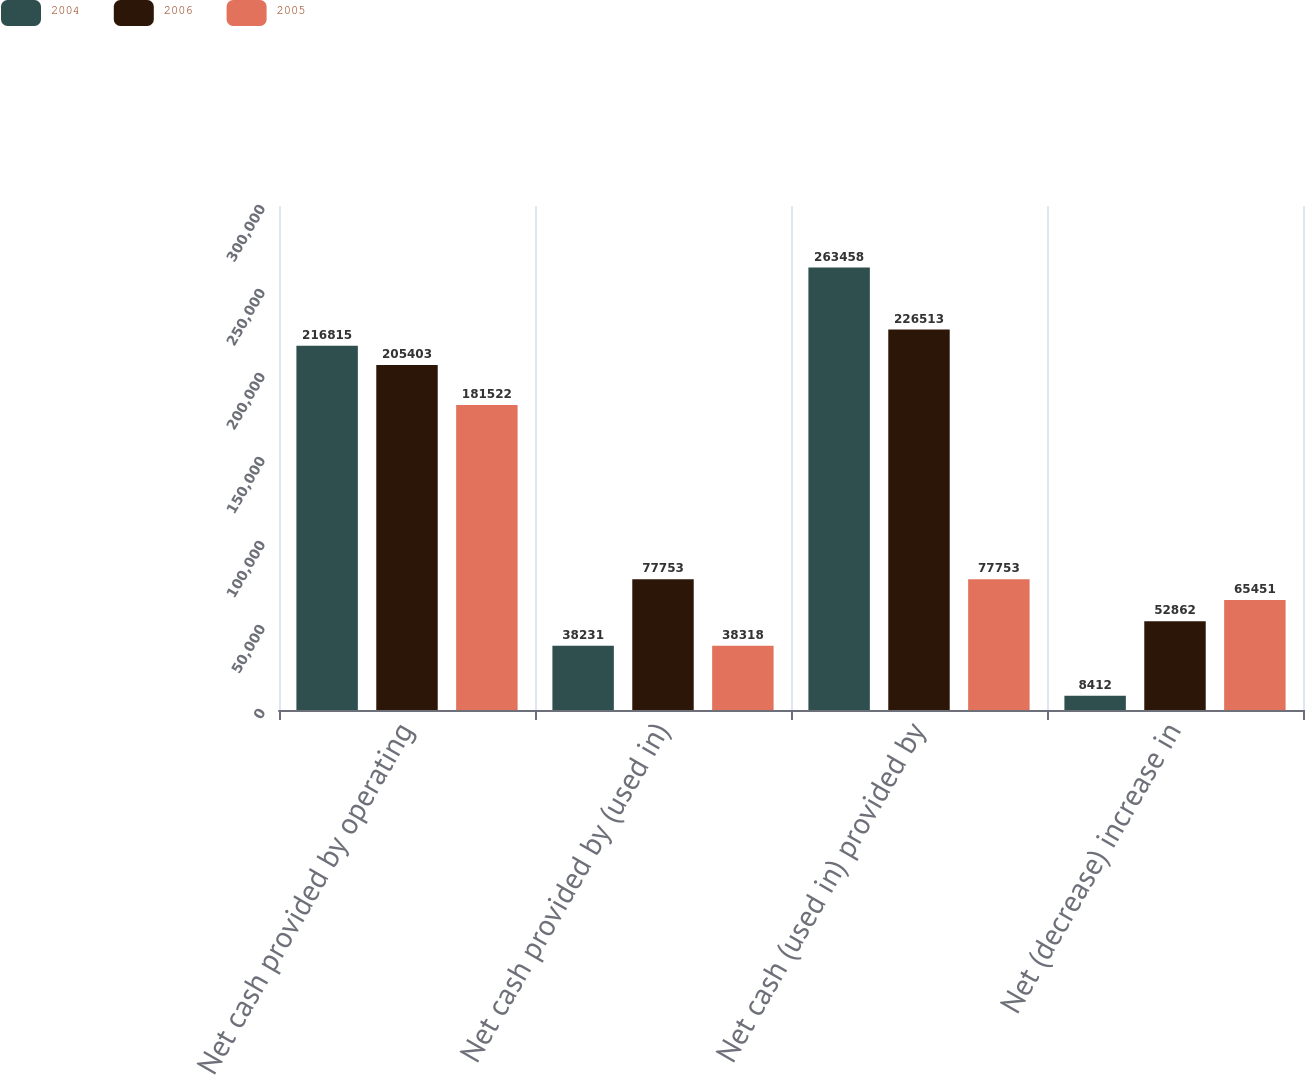Convert chart to OTSL. <chart><loc_0><loc_0><loc_500><loc_500><stacked_bar_chart><ecel><fcel>Net cash provided by operating<fcel>Net cash provided by (used in)<fcel>Net cash (used in) provided by<fcel>Net (decrease) increase in<nl><fcel>2004<fcel>216815<fcel>38231<fcel>263458<fcel>8412<nl><fcel>2006<fcel>205403<fcel>77753<fcel>226513<fcel>52862<nl><fcel>2005<fcel>181522<fcel>38318<fcel>77753<fcel>65451<nl></chart> 